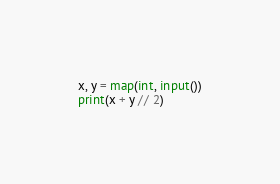Convert code to text. <code><loc_0><loc_0><loc_500><loc_500><_Python_>x, y = map(int, input())
print(x + y // 2)</code> 